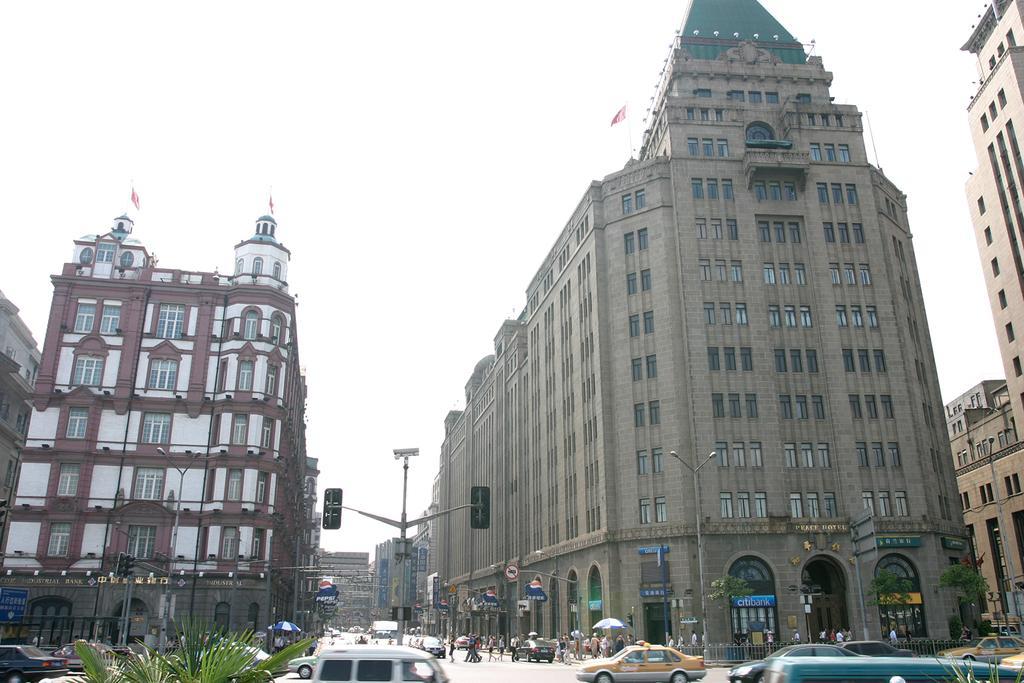Can you describe this image briefly? At the bottom of the image there is road with vehicles. And also there are leaves of a plant. There are poles with sign boards and traffic signals. In the background there are buildings with walls, windows, arches, pillars, roofs and flags. At the top of the image there is sky. 